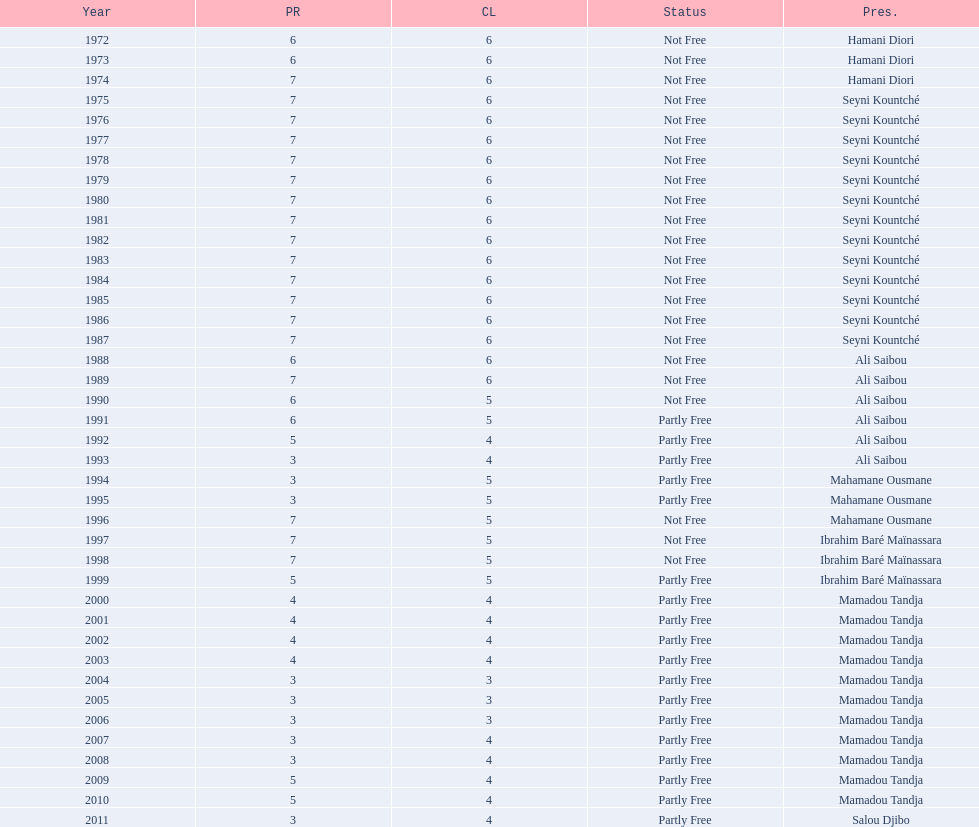Who was president before mamadou tandja? Ibrahim Baré Maïnassara. 